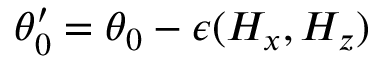Convert formula to latex. <formula><loc_0><loc_0><loc_500><loc_500>\theta _ { 0 } ^ { \prime } = \theta _ { 0 } - \epsilon ( H _ { x } , H _ { z } )</formula> 